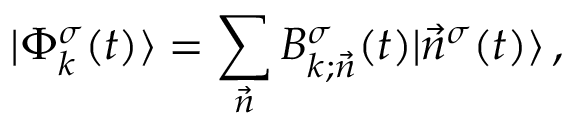Convert formula to latex. <formula><loc_0><loc_0><loc_500><loc_500>| \Phi _ { k } ^ { \sigma } ( t ) \rangle = \sum _ { \vec { n } } B _ { k ; \vec { n } } ^ { \sigma } ( t ) | \vec { n } ^ { \sigma } ( t ) \rangle \, ,</formula> 